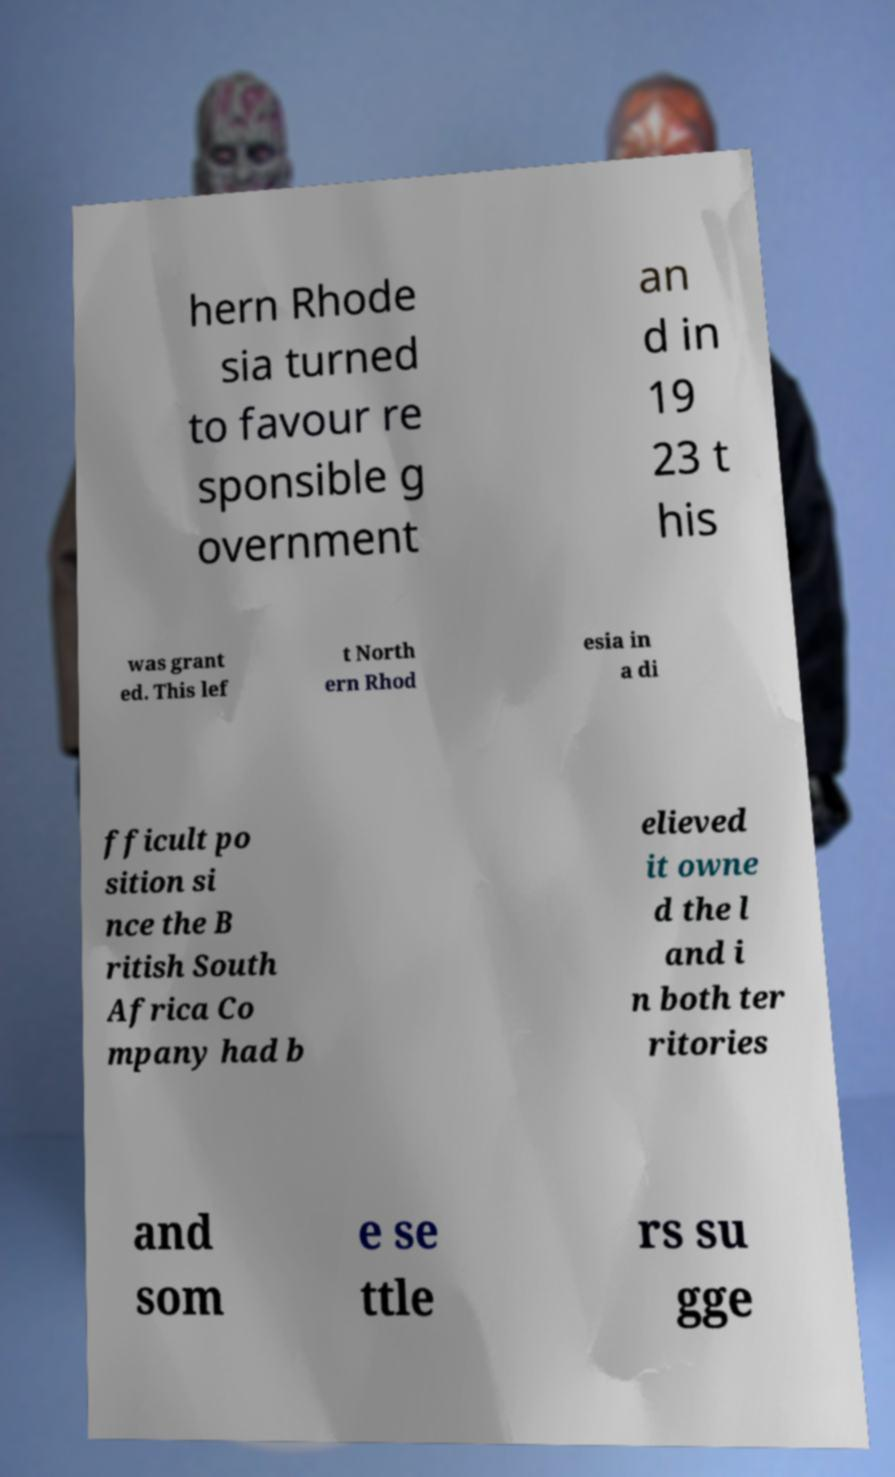Can you read and provide the text displayed in the image?This photo seems to have some interesting text. Can you extract and type it out for me? hern Rhode sia turned to favour re sponsible g overnment an d in 19 23 t his was grant ed. This lef t North ern Rhod esia in a di fficult po sition si nce the B ritish South Africa Co mpany had b elieved it owne d the l and i n both ter ritories and som e se ttle rs su gge 